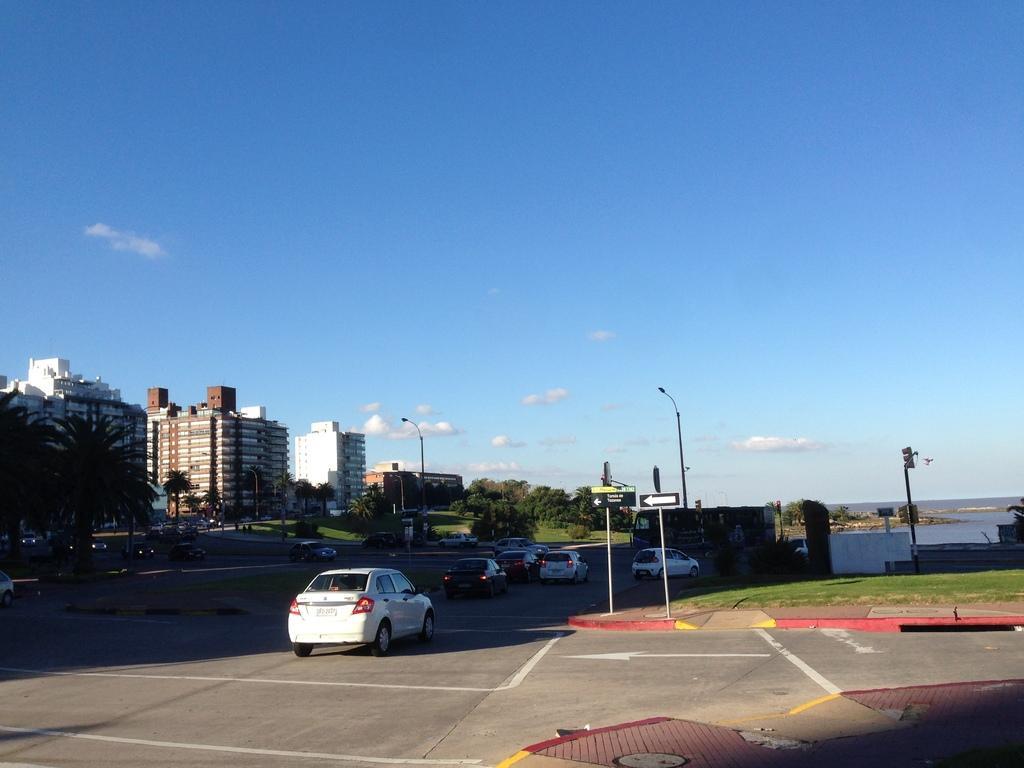How would you summarize this image in a sentence or two? In this image we can see a few vehicles on the road, few road signals, grass, few lights to the electric poles, few trees, few trees, water and some clouds in the sky. 